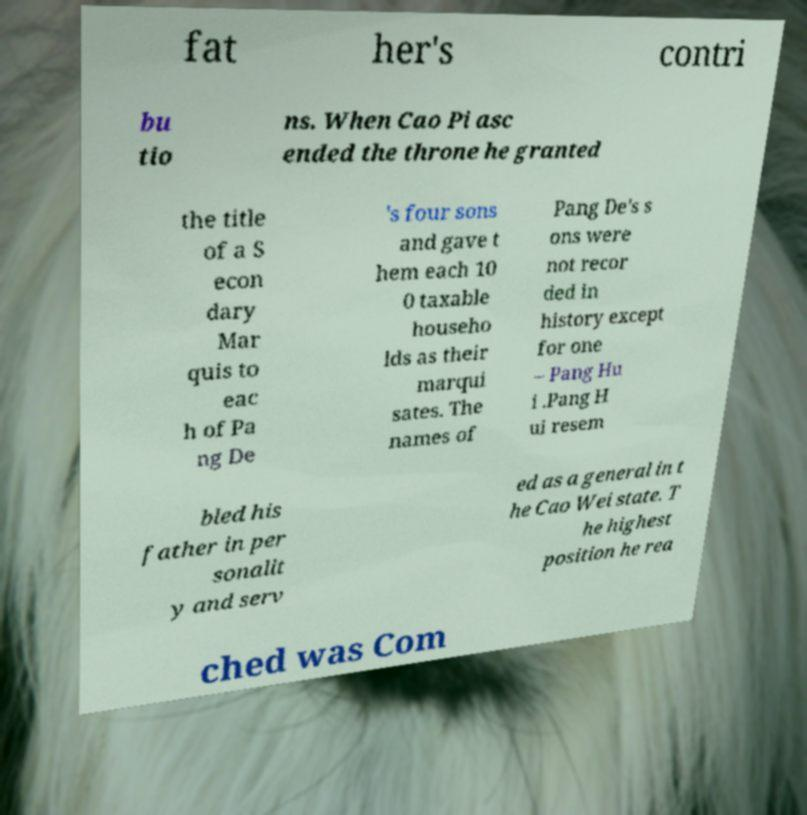There's text embedded in this image that I need extracted. Can you transcribe it verbatim? fat her's contri bu tio ns. When Cao Pi asc ended the throne he granted the title of a S econ dary Mar quis to eac h of Pa ng De 's four sons and gave t hem each 10 0 taxable househo lds as their marqui sates. The names of Pang De's s ons were not recor ded in history except for one – Pang Hu i .Pang H ui resem bled his father in per sonalit y and serv ed as a general in t he Cao Wei state. T he highest position he rea ched was Com 